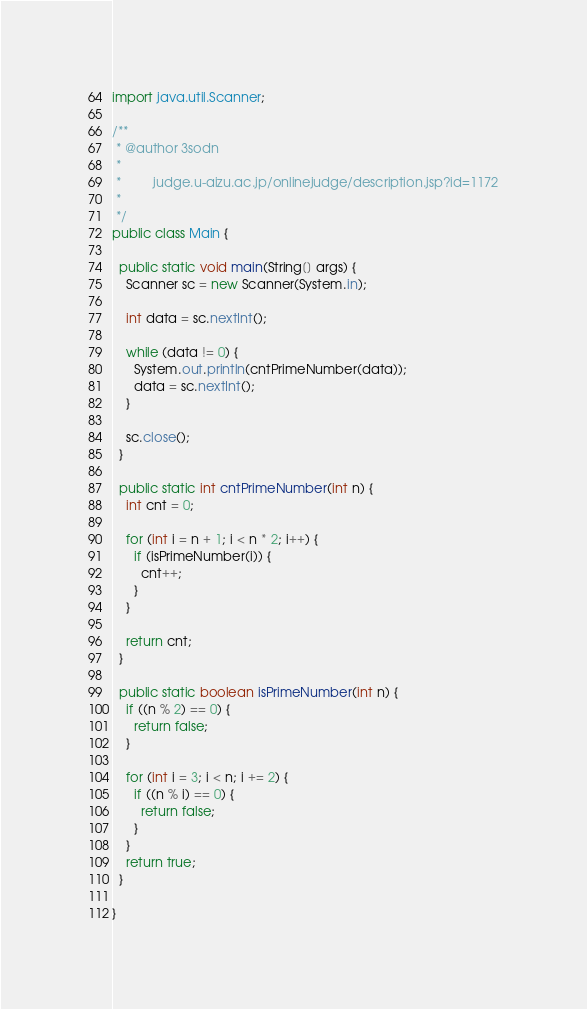<code> <loc_0><loc_0><loc_500><loc_500><_Java_>import java.util.Scanner;

/**
 * @author 3sodn
 * 
 *         judge.u-aizu.ac.jp/onlinejudge/description.jsp?id=1172
 *
 */
public class Main {

  public static void main(String[] args) {
    Scanner sc = new Scanner(System.in);

    int data = sc.nextInt();

    while (data != 0) {
      System.out.println(cntPrimeNumber(data));
      data = sc.nextInt();
    }

    sc.close();
  }

  public static int cntPrimeNumber(int n) {
    int cnt = 0;

    for (int i = n + 1; i < n * 2; i++) {
      if (isPrimeNumber(i)) {
        cnt++;
      }
    }

    return cnt;
  }

  public static boolean isPrimeNumber(int n) {
    if ((n % 2) == 0) {
      return false;
    }

    for (int i = 3; i < n; i += 2) {
      if ((n % i) == 0) {
        return false;
      }
    }
    return true;
  }

}</code> 